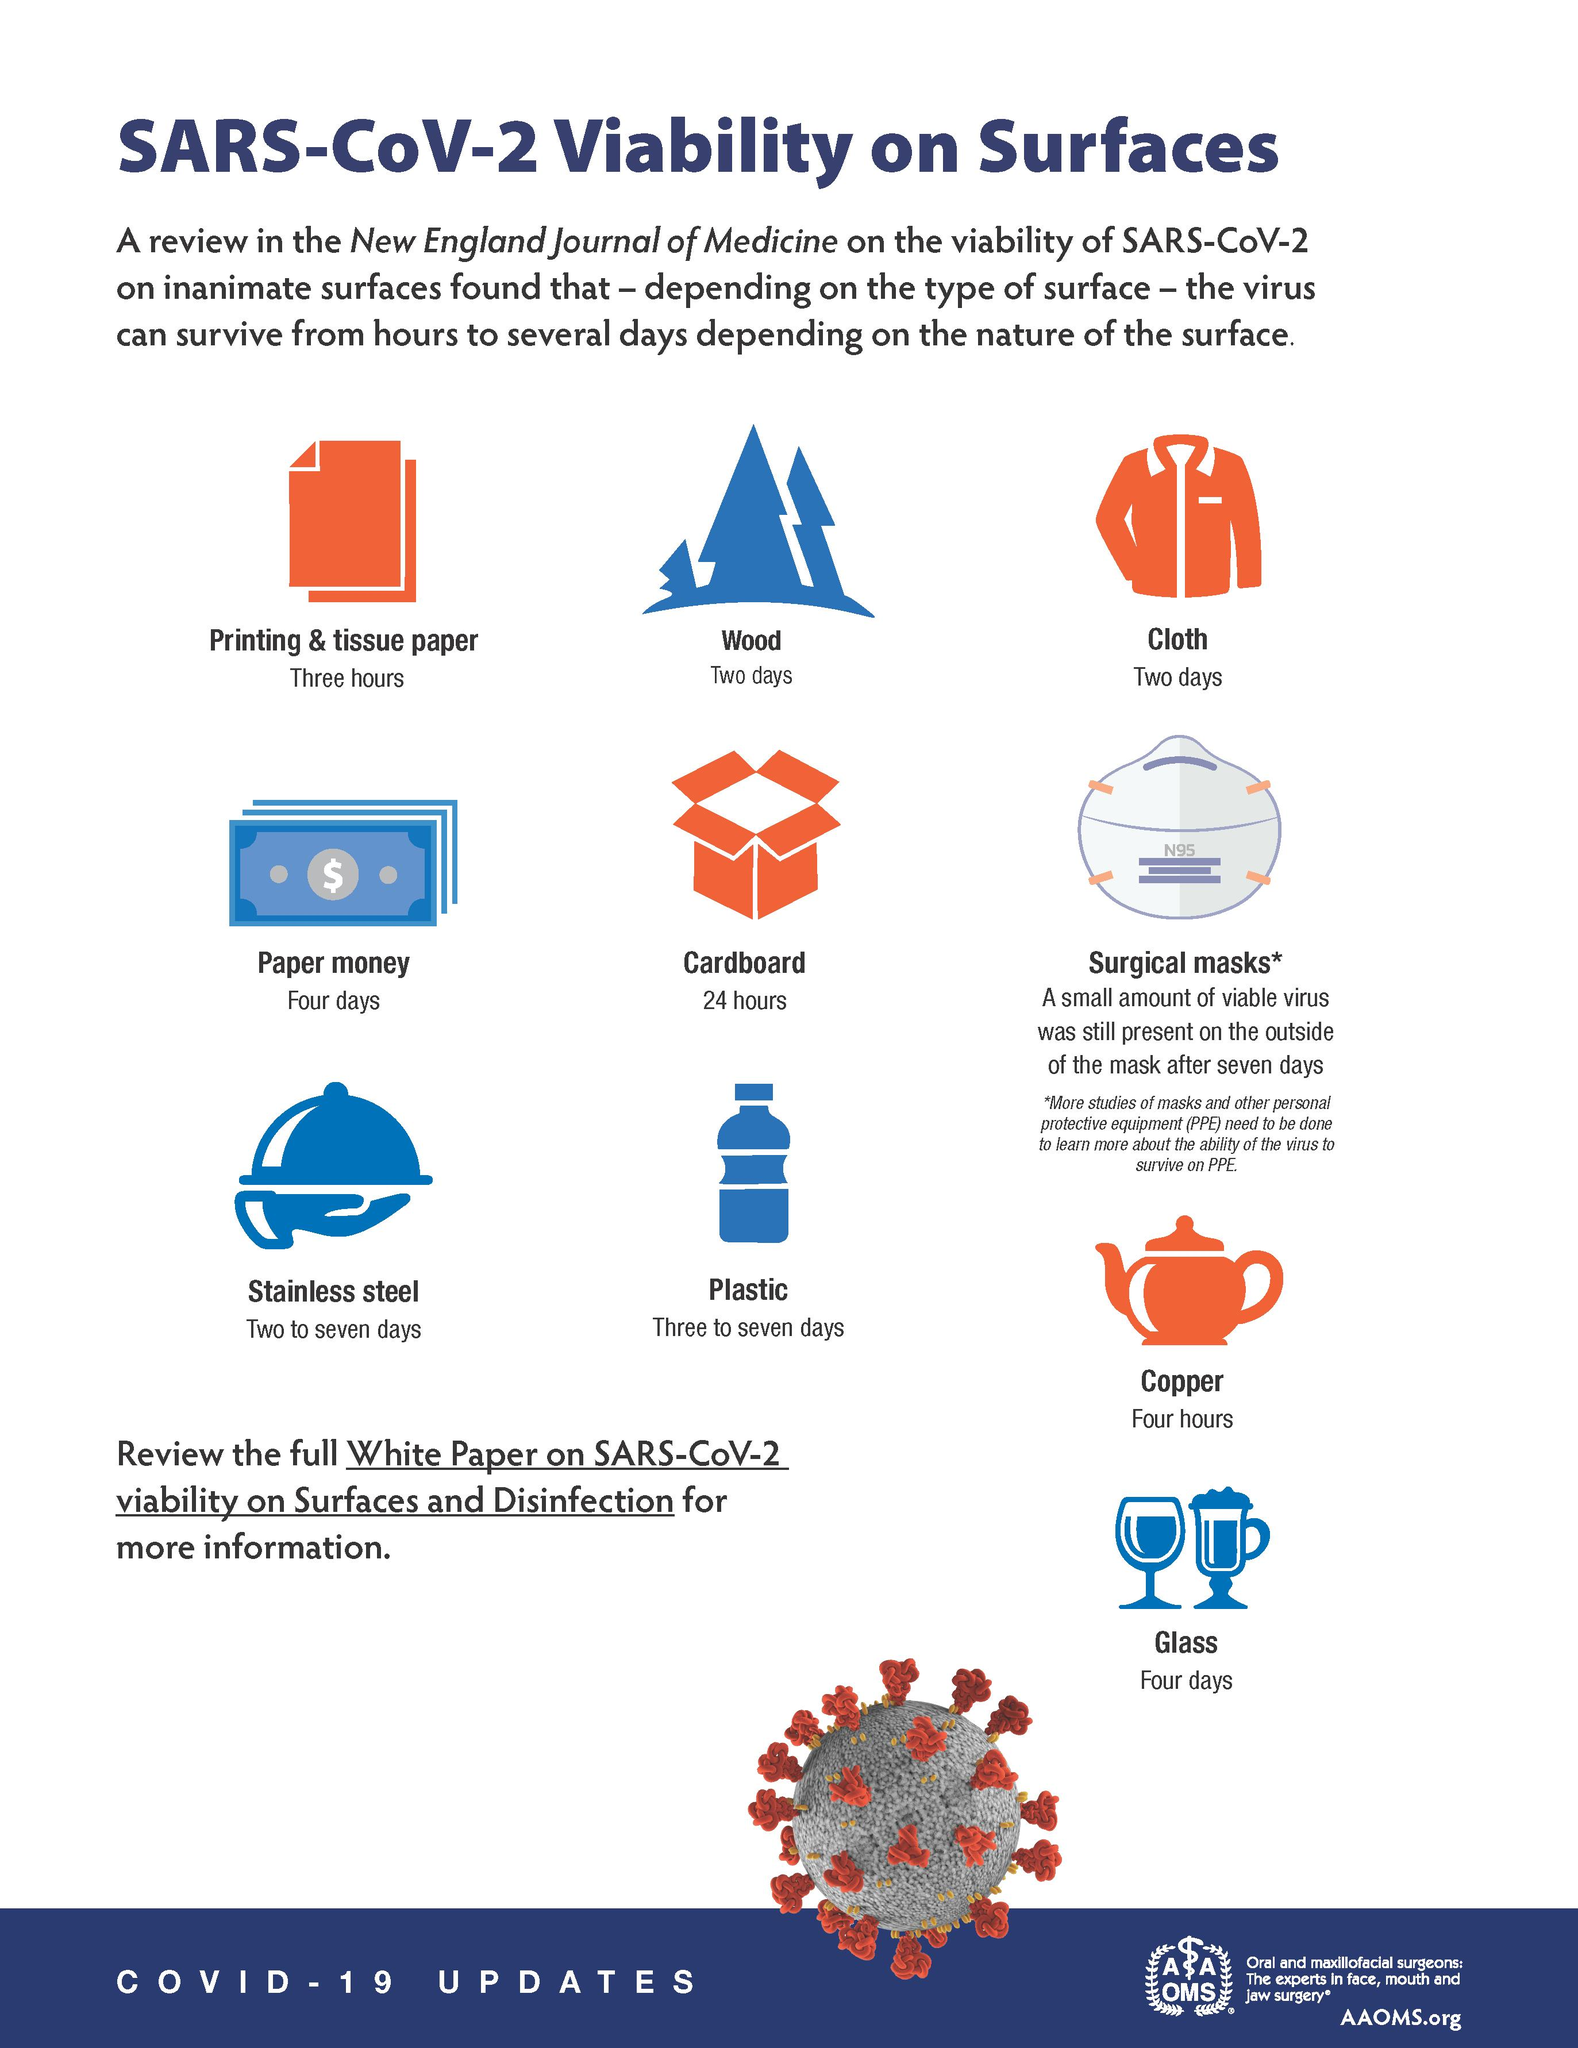Highlight a few significant elements in this photo. Surgical masks are the optimal surface for SARS-CoV-2 to remain for an extended period of time. The fourth surface mentioned in the infographic is paper money. Corona virus can survive for up to two days on surfaces made of wood and cloth. The Corona virus is expected to be active for 3 to 7 days on plastic surfaces. The SARS-CoV-2 virus can survive on stainless steel surfaces for two to seven days. 